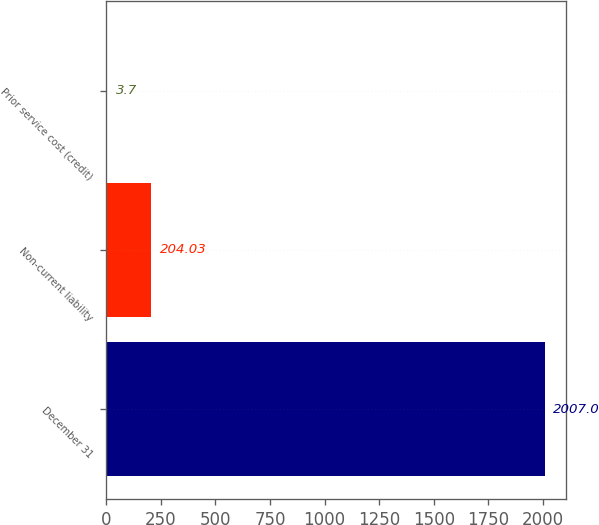Convert chart to OTSL. <chart><loc_0><loc_0><loc_500><loc_500><bar_chart><fcel>December 31<fcel>Non-current liability<fcel>Prior service cost (credit)<nl><fcel>2007<fcel>204.03<fcel>3.7<nl></chart> 